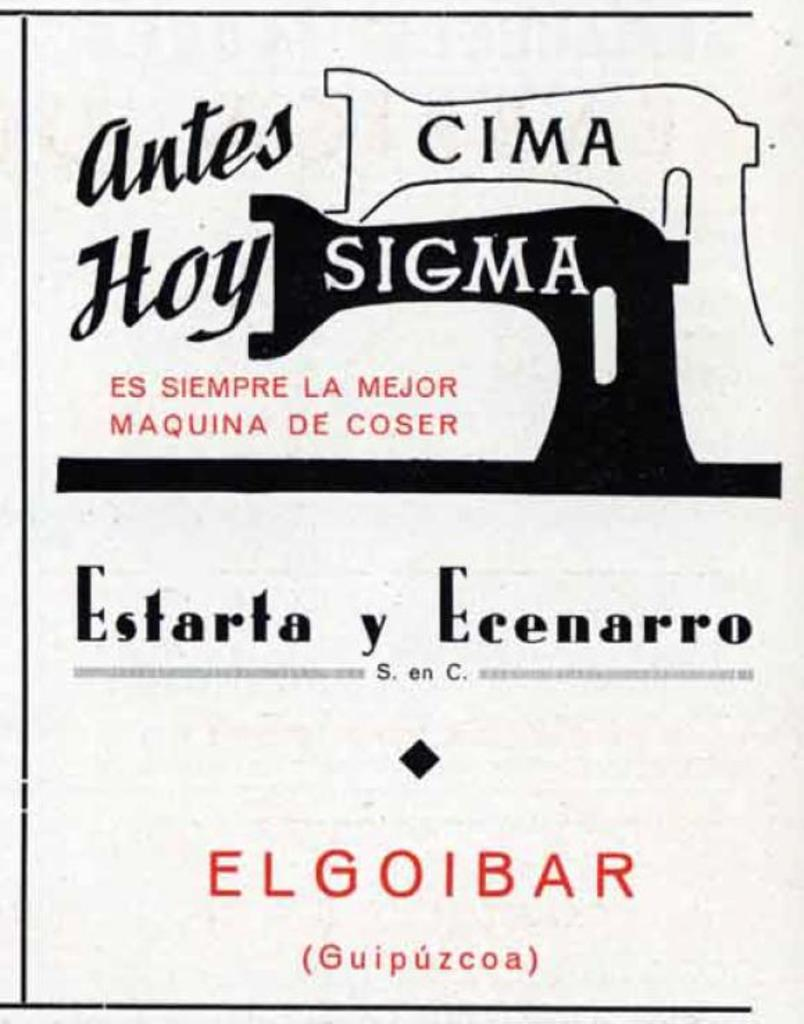<image>
Provide a brief description of the given image. Estarta y ecenarro antes cima hoy sigma banner 